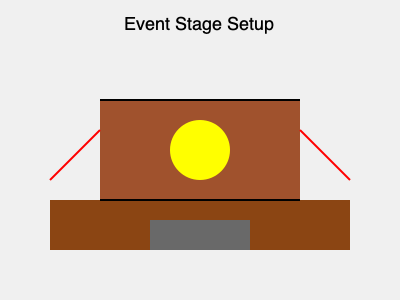In this 3D representation of an event stage setup, identify the most critical safety hazard that could potentially harm workers during construction or dismantling. To identify the most critical safety hazard in this event stage setup, let's analyze the elements step-by-step:

1. The base structure: A solid platform (brown rectangle) serves as the stage floor.

2. The upper structure: A raised platform or backdrop (darker brown rectangle) is placed on top of the base.

3. Lighting: A circular yellow object represents a lighting fixture or spotlight.

4. Access points: There are no visible ladders or stairs, which could be a minor safety concern.

5. Structural support: Two red diagonal lines extend from the edges of the base to the upper structure.

The most critical safety hazard in this setup is the lack of proper structural support. The red diagonal lines likely represent temporary or inadequate support structures.

Inadequate support poses severe risks:
a) Collapse during construction or dismantling
b) Instability during the event
c) Danger to workers accessing the upper level

This hazard directly relates to fair labor practices, as proper safety measures are essential for protecting workers' well-being.
Answer: Inadequate structural support 